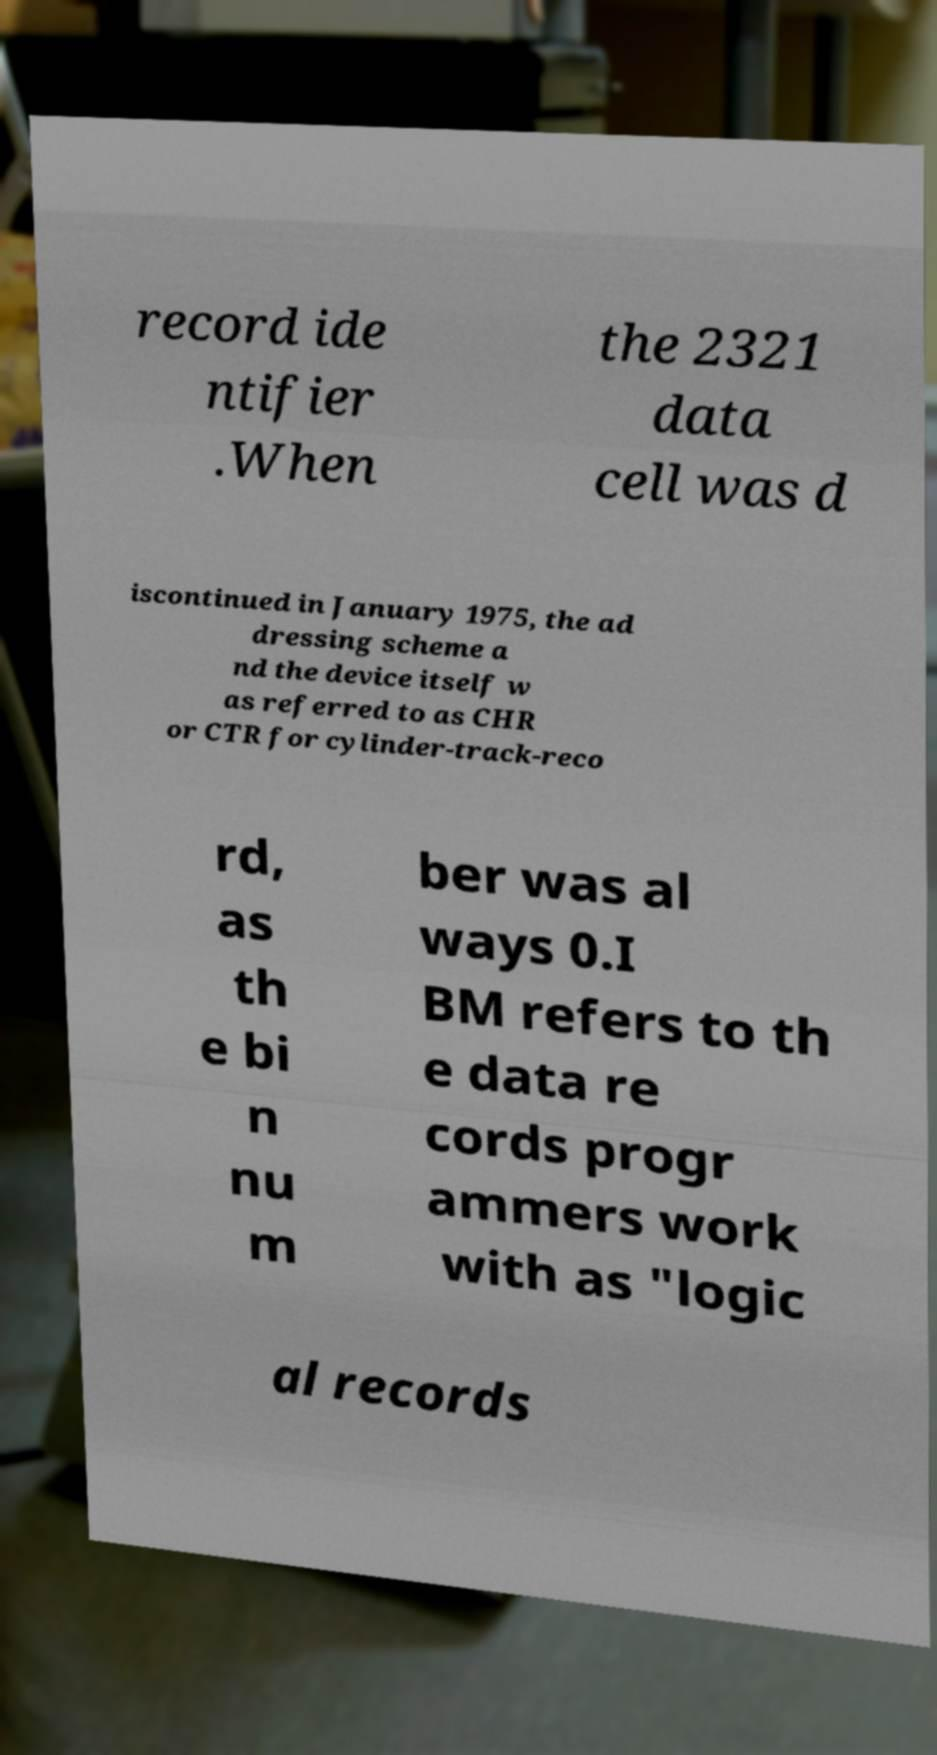Could you extract and type out the text from this image? record ide ntifier .When the 2321 data cell was d iscontinued in January 1975, the ad dressing scheme a nd the device itself w as referred to as CHR or CTR for cylinder-track-reco rd, as th e bi n nu m ber was al ways 0.I BM refers to th e data re cords progr ammers work with as "logic al records 